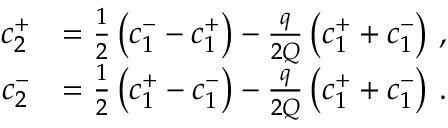Convert formula to latex. <formula><loc_0><loc_0><loc_500><loc_500>\begin{array} { r l } { c _ { 2 } ^ { + } } & { = \frac { 1 } { 2 } \left ( c _ { 1 } ^ { - } - c _ { 1 } ^ { + } \right ) - \frac { q } { 2 Q } \left ( c _ { 1 } ^ { + } + c _ { 1 } ^ { - } \right ) \, , } \\ { c _ { 2 } ^ { - } } & { = \frac { 1 } { 2 } \left ( c _ { 1 } ^ { + } - c _ { 1 } ^ { - } \right ) - \frac { q } { 2 Q } \left ( c _ { 1 } ^ { + } + c _ { 1 } ^ { - } \right ) \, . } \end{array}</formula> 